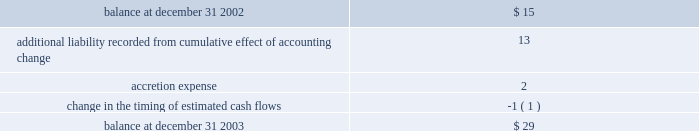Impairment of long-lived assets based on the projection of undiscounted cash flows whenever events or changes in circumstances indicate that the carrying amounts of such assets may not be recoverable .
In the event such cash flows are not expected to be sufficient to recover the recorded value of the assets , the assets are written down to their estimated fair values ( see note 5 ) .
Asset retirement obligations 2014effective january 1 , 2003 , the company adopted statement of financial accounting standards ( 2018 2018sfas 2019 2019 ) no .
143 , 2018 2018accounting for asset retirement obligations . 2019 2019 sfas no .
143 requires the company to record the fair value of a legal liability for an asset retirement obligation in the period in which it is incurred .
When a new liability is recorded the company will capitalize the costs of the liability by increasing the carrying amount of the related long-lived asset .
The liability is accreted to its present value each period and the capitalized cost is depreciated over the useful life of the related asset .
Upon settlement of the liability , the company settles the obligation for its recorded amount or incurs a gain or loss upon settlement .
The company 2019s retirement obligations covered by sfas no .
143 include primarily active ash landfills , water treatment basins and the removal or dismantlement of certain plant and equipment .
As of december 31 , 2003 and 2002 , the company had recorded liabilities of approximately $ 29 million and $ 15 million , respectively , related to asset retirement obligations .
There are no assets that are legally restricted for purposes of settling asset retirement obligations .
Upon adoption of sfas no .
143 , the company recorded an additional liability of approximately $ 13 million , a net asset of approximately $ 9 million , and a cumulative effect of a change in accounting principle of approximately $ 2 million , after income taxes .
Amounts recorded related to asset retirement obligations during the years ended december 31 , 2003 were as follows ( in millions ) : .
Proforma net ( loss ) income and ( loss ) earnings per share have not been presented for the years ended december 31 , 2002 and 2001 because the proforma application of sfas no .
143 to prior periods would result in proforma net ( loss ) income and ( loss ) earnings per share not materially different from the actual amounts reported for those periods in the accompanying consolidated statements of operations .
Had sfas 143 been applied during all periods presented the asset retirement obligation at january 1 , 2001 , december 31 , 2001 and december 31 , 2002 would have been approximately $ 21 million , $ 23 million and $ 28 million , respectively .
Included in other long-term liabilities is the accrual for the non-legal obligations for removal of assets in service at ipalco amounting to $ 361 million and $ 339 million at december 31 , 2003 and 2002 , respectively .
Deferred financing costs 2014financing costs are deferred and amortized over the related financing period using the effective interest method or the straight-line method when it does not differ materially from the effective interest method .
Deferred financing costs are shown net of accumulated amortization of $ 202 million and $ 173 million as of december 31 , 2003 and 2002 , respectively .
Project development costs 2014the company capitalizes the costs of developing new construction projects after achieving certain project-related milestones that indicate the project 2019s completion is probable .
These costs represent amounts incurred for professional services , permits , options , capitalized interest , and other costs directly related to construction .
These costs are transferred to construction in progress when significant construction activity commences , or expensed at the time the company determines that development of a particular project is no longer probable ( see note 5 ) . .
Without the accounting change , what would the aro balance have been ( millions ) at december 31 2003? 
Computations: (29 - 13)
Answer: 16.0. 